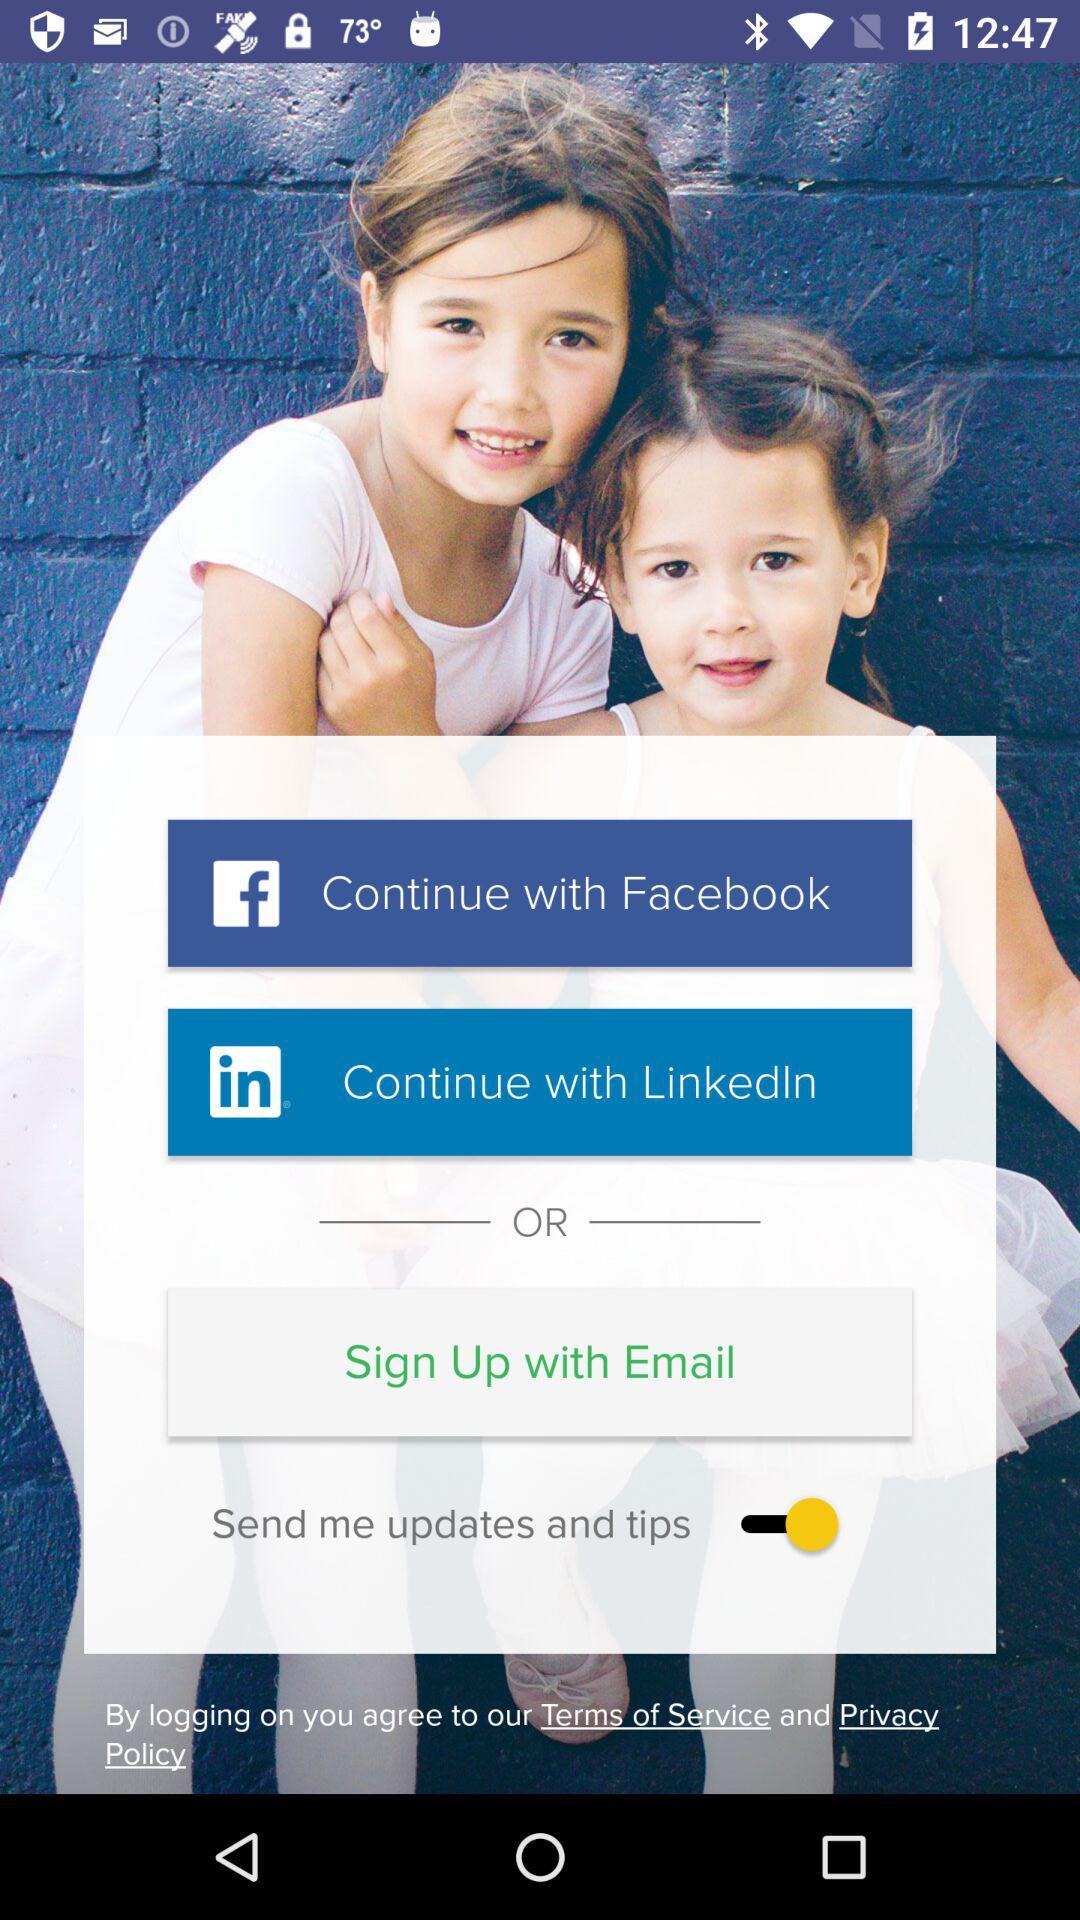What accounts can I use to sign up? The accounts you can use to sign up are "Facebook", "LinkedIn" and "Email". 